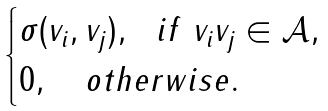Convert formula to latex. <formula><loc_0><loc_0><loc_500><loc_500>\begin{cases} \sigma ( v _ { i } , v _ { j } ) , \ \ i f \ v _ { i } v _ { j } \in \mathcal { A } , \\ 0 , \quad o t h e r w i s e . \end{cases}</formula> 